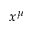<formula> <loc_0><loc_0><loc_500><loc_500>x ^ { \mu }</formula> 